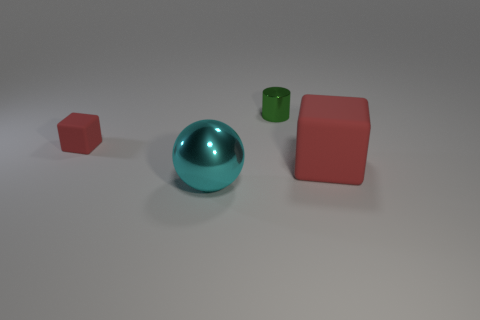What is the size of the rubber block behind the red matte cube right of the small red cube that is in front of the small green cylinder?
Your response must be concise. Small. Is there a rubber block of the same color as the big metallic object?
Ensure brevity in your answer.  No. What number of green shiny objects are there?
Your response must be concise. 1. What material is the block to the right of the matte cube that is on the left side of the red thing to the right of the big cyan thing?
Provide a short and direct response. Rubber. Is there a thing made of the same material as the ball?
Offer a terse response. Yes. Are the small red thing and the cylinder made of the same material?
Make the answer very short. No. What number of blocks are either big brown objects or matte things?
Offer a very short reply. 2. What color is the object that is the same material as the cylinder?
Your answer should be very brief. Cyan. Are there fewer green shiny cylinders than large blue blocks?
Give a very brief answer. No. Is the shape of the red thing left of the green object the same as the red rubber object in front of the small red rubber block?
Your answer should be very brief. Yes. 